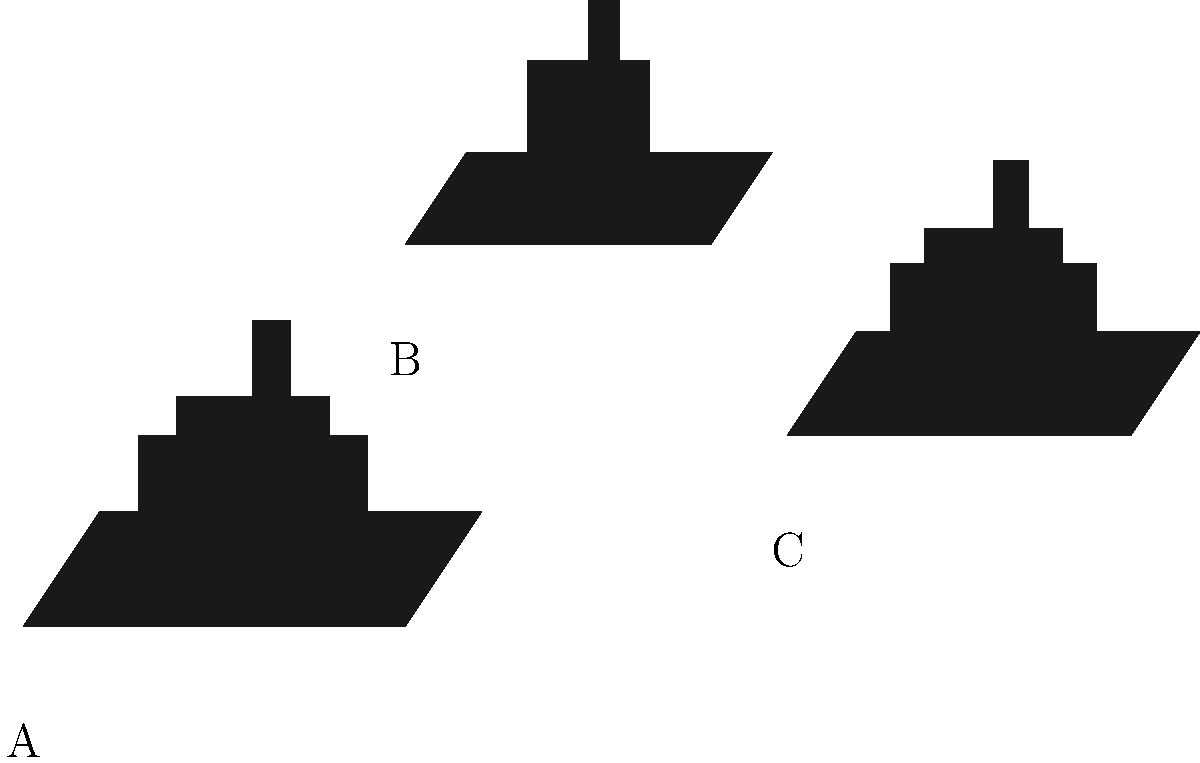Identify which of the ship silhouettes (A, B, or C) represents a cruiser used in World War I naval battles. Explain your reasoning based on the characteristics visible in the image. To identify the cruiser among the ship silhouettes, we need to analyze the characteristics of each ship:

1. Ship A:
   - Large size
   - Two distinct turrets visible
   - Substantial superstructure
   - These features indicate a battleship

2. Ship B:
   - Smaller size compared to A and C
   - No visible large turrets
   - Single funnel and simpler superstructure
   - These features are consistent with a cruiser

3. Ship C:
   - Large size, similar to A
   - Two distinct turrets visible
   - Substantial superstructure
   - These features indicate another battleship

Cruisers in World War I were generally smaller than battleships, with less armor and fewer large guns. They were designed for speed and versatility, often used for scouting and supporting larger ships.

The lack of visible large turrets and the smaller overall size of Ship B are key indicators that it represents a cruiser, while Ships A and C have the characteristics of battleships with their larger size and prominent gun turrets.
Answer: B 